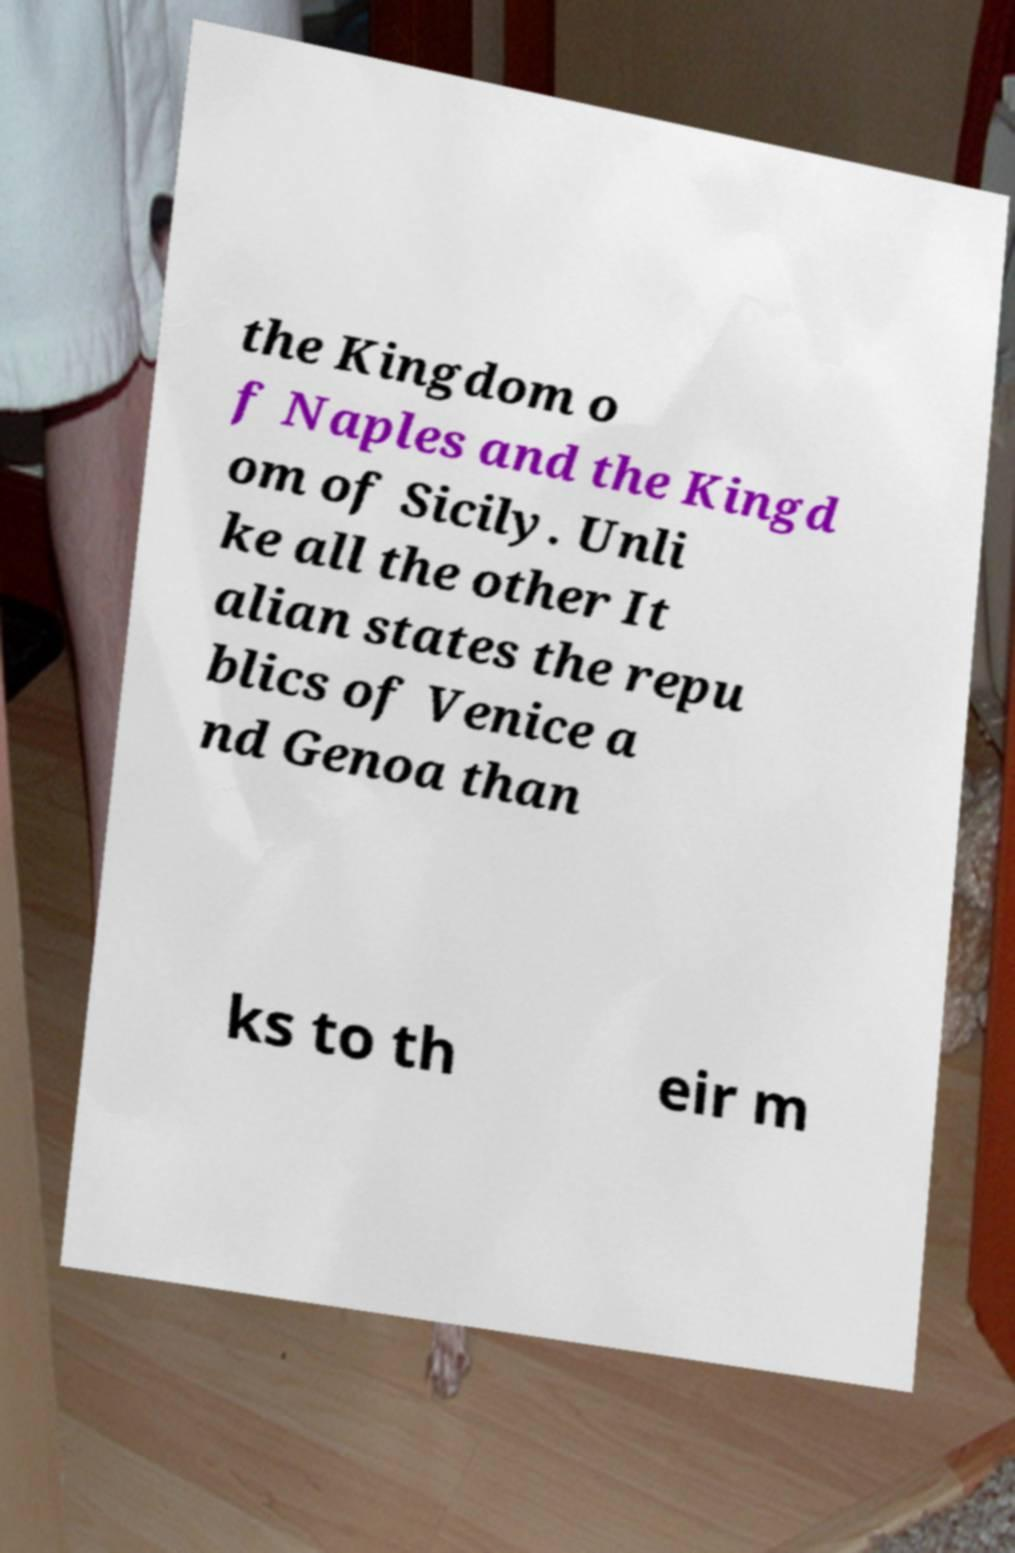Can you accurately transcribe the text from the provided image for me? the Kingdom o f Naples and the Kingd om of Sicily. Unli ke all the other It alian states the repu blics of Venice a nd Genoa than ks to th eir m 